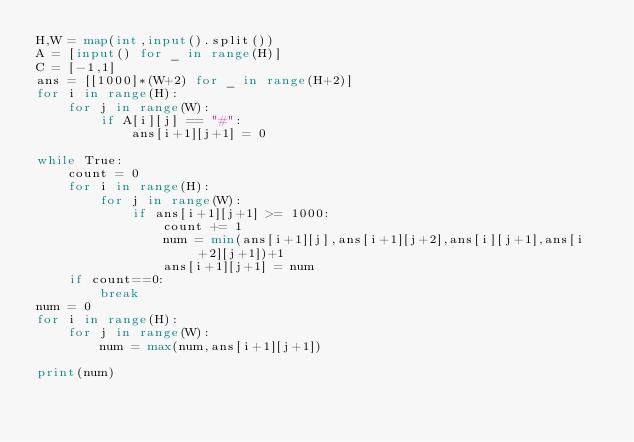<code> <loc_0><loc_0><loc_500><loc_500><_Python_>H,W = map(int,input().split())
A = [input() for _ in range(H)]
C = [-1,1]
ans = [[1000]*(W+2) for _ in range(H+2)]
for i in range(H):
    for j in range(W):
        if A[i][j] == "#":
            ans[i+1][j+1] = 0

while True:
    count = 0
    for i in range(H):
        for j in range(W):
            if ans[i+1][j+1] >= 1000:
                count += 1
                num = min(ans[i+1][j],ans[i+1][j+2],ans[i][j+1],ans[i+2][j+1])+1
                ans[i+1][j+1] = num
    if count==0:
        break
num = 0
for i in range(H):
    for j in range(W):
        num = max(num,ans[i+1][j+1])

print(num)</code> 